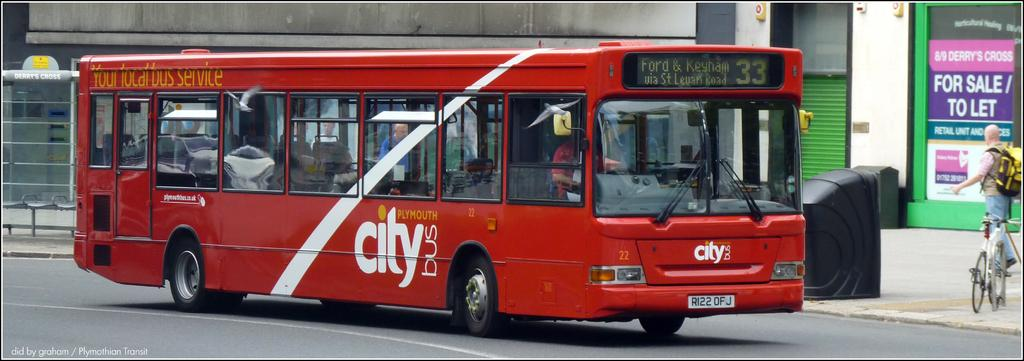What is the main subject in the foreground of the image? There is a bus in the foreground of the image. Where is the bus located? The bus is on the road. Can you describe anything or anyone on the right side of the image? There is a person standing on the right side of the image. What type of step is the bear using to climb the bus in the image? There is no bear present in the image, and therefore no steps or climbing activity can be observed. 